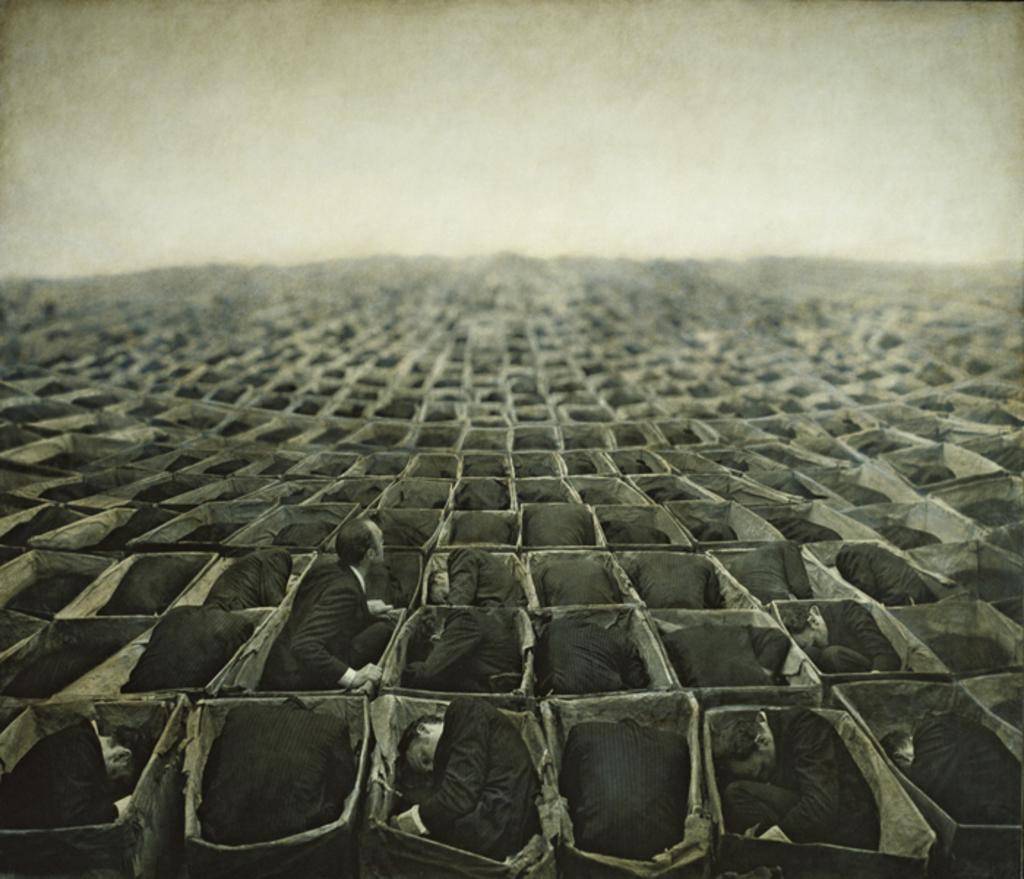What is inside the box in the image? There are bodies in the box in the image. What color scheme is used in the image? The image is in black and white. What type of base is used to support the bodies in the image? There is no information about a base in the image, as it only shows bodies in a box. Are the bodies wearing any suits in the image? There is no information about suits or clothing on the bodies in the image. 